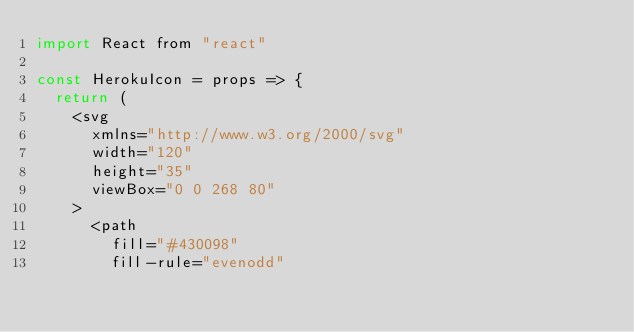<code> <loc_0><loc_0><loc_500><loc_500><_JavaScript_>import React from "react"

const HerokuIcon = props => {
  return (
    <svg
      xmlns="http://www.w3.org/2000/svg"
      width="120"
      height="35"
      viewBox="0 0 268 80"
    >
      <path
        fill="#430098"
        fill-rule="evenodd"</code> 